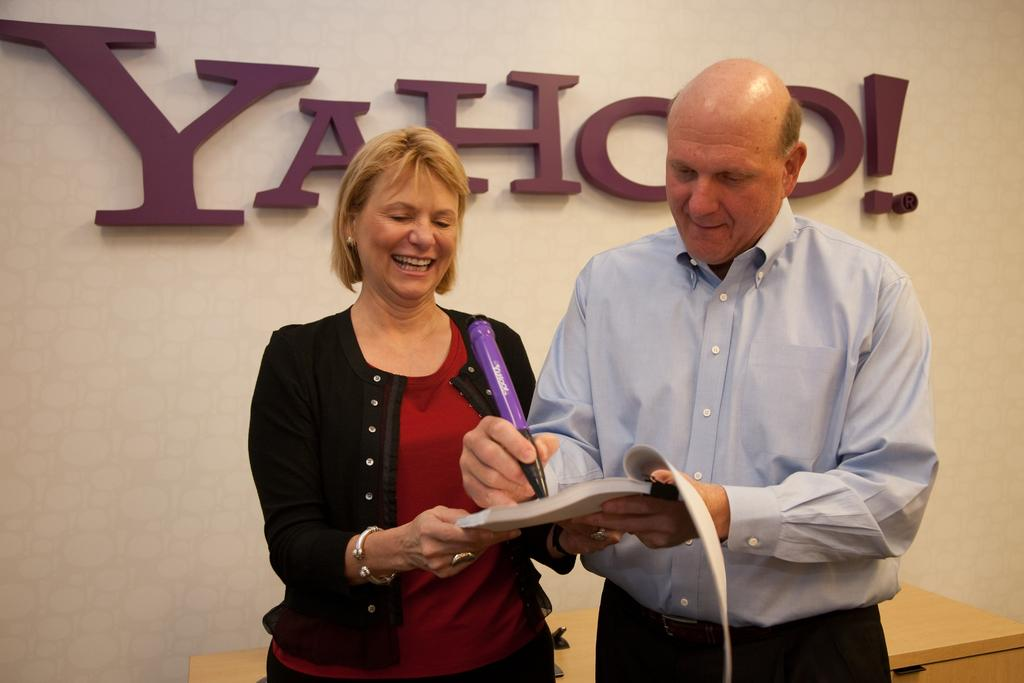How many people are in the image? There are two people in the image. What are the people holding in the image? Both people are holding a book. Can you describe the woman's expression in the image? The woman is smiling. What is the man holding in addition to the book? The man is holding a pen. What can be seen in the background of the image? There is a wall and a table in the background of the image. What type of straw is the woman using to sip her drink in the image? There is no drink or straw present in the image; the woman is holding a book and smiling. 